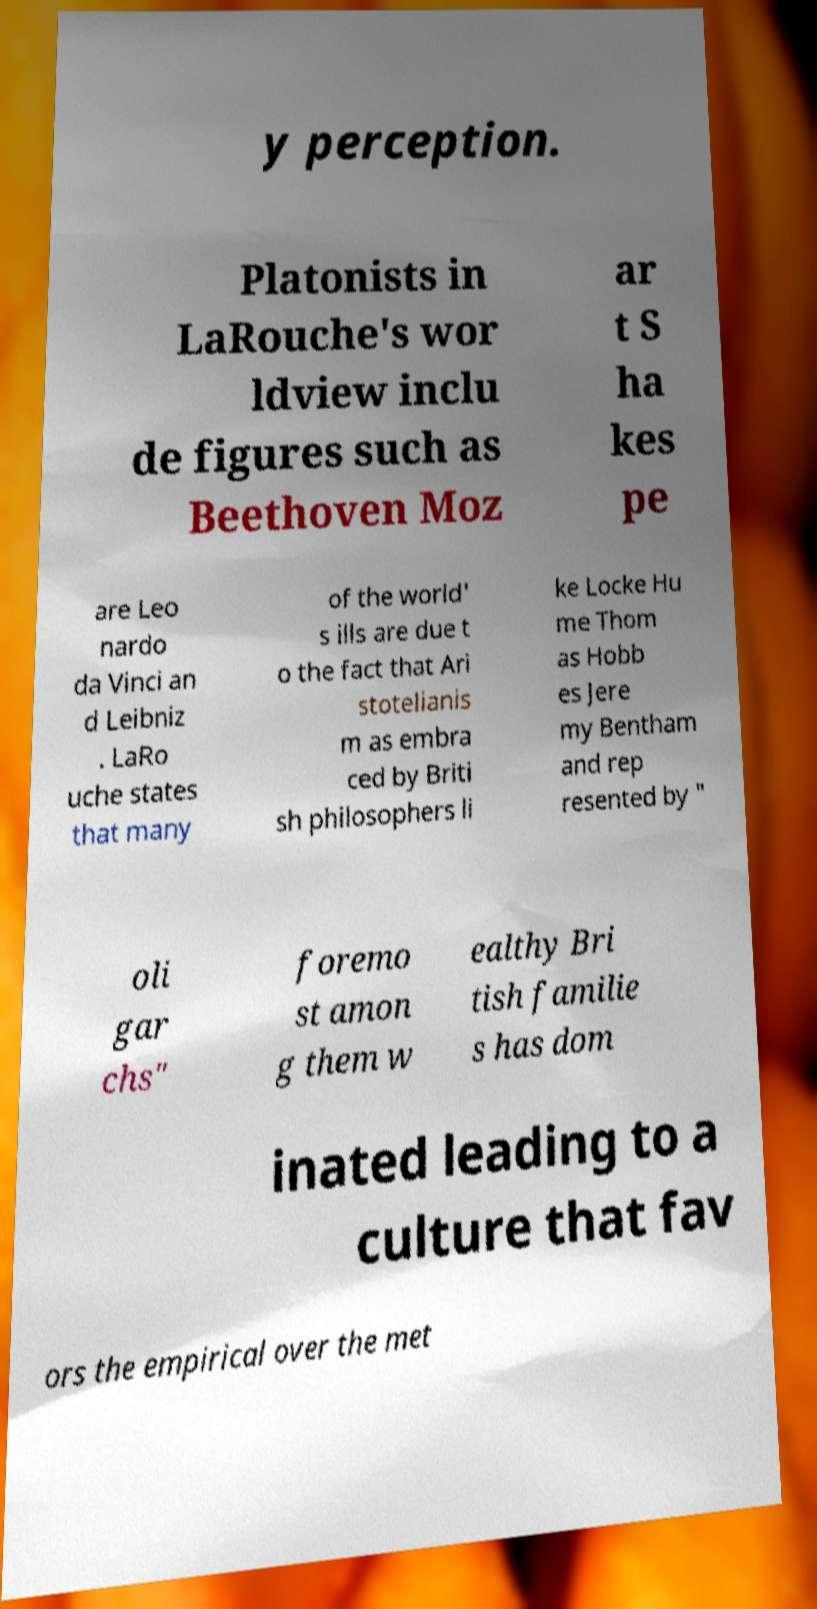Can you read and provide the text displayed in the image?This photo seems to have some interesting text. Can you extract and type it out for me? y perception. Platonists in LaRouche's wor ldview inclu de figures such as Beethoven Moz ar t S ha kes pe are Leo nardo da Vinci an d Leibniz . LaRo uche states that many of the world' s ills are due t o the fact that Ari stotelianis m as embra ced by Briti sh philosophers li ke Locke Hu me Thom as Hobb es Jere my Bentham and rep resented by " oli gar chs" foremo st amon g them w ealthy Bri tish familie s has dom inated leading to a culture that fav ors the empirical over the met 